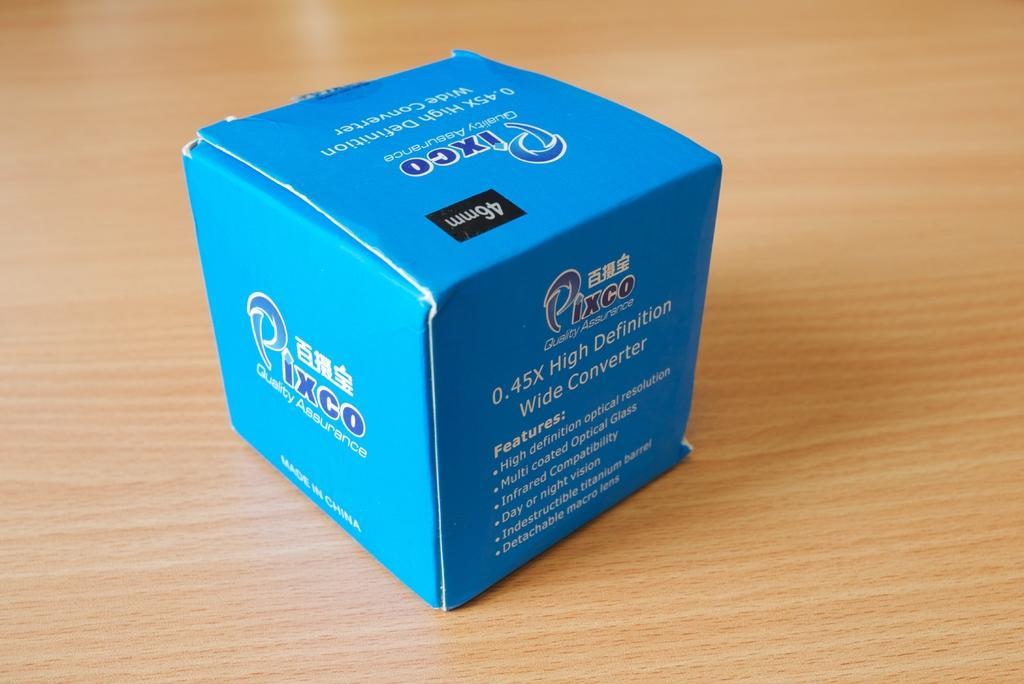How would you summarize this image in a sentence or two? In this picture there is a blue color box which has something written on it is placed on a brown surface. 